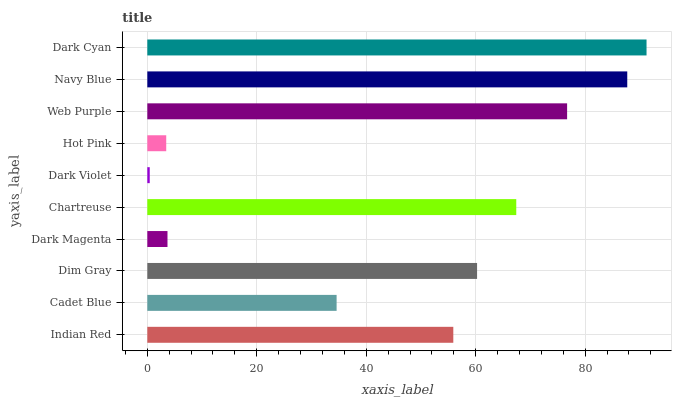Is Dark Violet the minimum?
Answer yes or no. Yes. Is Dark Cyan the maximum?
Answer yes or no. Yes. Is Cadet Blue the minimum?
Answer yes or no. No. Is Cadet Blue the maximum?
Answer yes or no. No. Is Indian Red greater than Cadet Blue?
Answer yes or no. Yes. Is Cadet Blue less than Indian Red?
Answer yes or no. Yes. Is Cadet Blue greater than Indian Red?
Answer yes or no. No. Is Indian Red less than Cadet Blue?
Answer yes or no. No. Is Dim Gray the high median?
Answer yes or no. Yes. Is Indian Red the low median?
Answer yes or no. Yes. Is Indian Red the high median?
Answer yes or no. No. Is Hot Pink the low median?
Answer yes or no. No. 